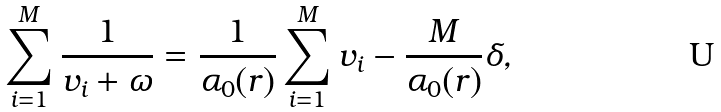<formula> <loc_0><loc_0><loc_500><loc_500>\sum _ { i = 1 } ^ { M } \frac { 1 } { v _ { i } + \omega } = \frac { 1 } { \alpha _ { 0 } ( r ) } \sum _ { i = 1 } ^ { M } v _ { i } - \frac { M } { \alpha _ { 0 } ( r ) } \delta ,</formula> 